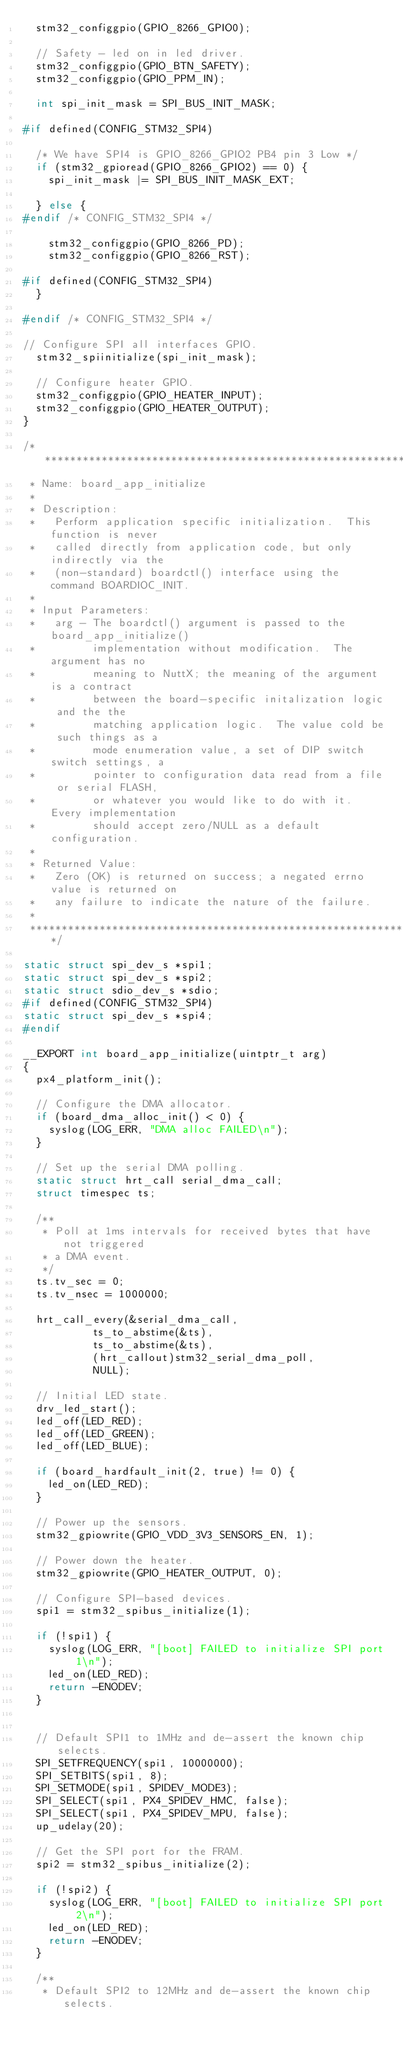Convert code to text. <code><loc_0><loc_0><loc_500><loc_500><_C_>	stm32_configgpio(GPIO_8266_GPIO0);

	// Safety - led on in led driver.
	stm32_configgpio(GPIO_BTN_SAFETY);
	stm32_configgpio(GPIO_PPM_IN);

	int spi_init_mask = SPI_BUS_INIT_MASK;

#if defined(CONFIG_STM32_SPI4)

	/* We have SPI4 is GPIO_8266_GPIO2 PB4 pin 3 Low */
	if (stm32_gpioread(GPIO_8266_GPIO2) == 0) {
		spi_init_mask |= SPI_BUS_INIT_MASK_EXT;

	} else {
#endif /* CONFIG_STM32_SPI4 */

		stm32_configgpio(GPIO_8266_PD);
		stm32_configgpio(GPIO_8266_RST);

#if defined(CONFIG_STM32_SPI4)
	}

#endif /* CONFIG_STM32_SPI4 */

// Configure SPI all interfaces GPIO.
	stm32_spiinitialize(spi_init_mask);

	// Configure heater GPIO.
	stm32_configgpio(GPIO_HEATER_INPUT);
	stm32_configgpio(GPIO_HEATER_OUTPUT);
}

/****************************************************************************
 * Name: board_app_initialize
 *
 * Description:
 *   Perform application specific initialization.  This function is never
 *   called directly from application code, but only indirectly via the
 *   (non-standard) boardctl() interface using the command BOARDIOC_INIT.
 *
 * Input Parameters:
 *   arg - The boardctl() argument is passed to the board_app_initialize()
 *         implementation without modification.  The argument has no
 *         meaning to NuttX; the meaning of the argument is a contract
 *         between the board-specific initalization logic and the the
 *         matching application logic.  The value cold be such things as a
 *         mode enumeration value, a set of DIP switch switch settings, a
 *         pointer to configuration data read from a file or serial FLASH,
 *         or whatever you would like to do with it.  Every implementation
 *         should accept zero/NULL as a default configuration.
 *
 * Returned Value:
 *   Zero (OK) is returned on success; a negated errno value is returned on
 *   any failure to indicate the nature of the failure.
 *
 ****************************************************************************/

static struct spi_dev_s *spi1;
static struct spi_dev_s *spi2;
static struct sdio_dev_s *sdio;
#if defined(CONFIG_STM32_SPI4)
static struct spi_dev_s *spi4;
#endif

__EXPORT int board_app_initialize(uintptr_t arg)
{
	px4_platform_init();

	// Configure the DMA allocator.
	if (board_dma_alloc_init() < 0) {
		syslog(LOG_ERR, "DMA alloc FAILED\n");
	}

	// Set up the serial DMA polling.
	static struct hrt_call serial_dma_call;
	struct timespec ts;

	/**
	 * Poll at 1ms intervals for received bytes that have not triggered
	 * a DMA event.
	 */
	ts.tv_sec = 0;
	ts.tv_nsec = 1000000;

	hrt_call_every(&serial_dma_call,
		       ts_to_abstime(&ts),
		       ts_to_abstime(&ts),
		       (hrt_callout)stm32_serial_dma_poll,
		       NULL);

	// Initial LED state.
	drv_led_start();
	led_off(LED_RED);
	led_off(LED_GREEN);
	led_off(LED_BLUE);

	if (board_hardfault_init(2, true) != 0) {
		led_on(LED_RED);
	}

	// Power up the sensors.
	stm32_gpiowrite(GPIO_VDD_3V3_SENSORS_EN, 1);

	// Power down the heater.
	stm32_gpiowrite(GPIO_HEATER_OUTPUT, 0);

	// Configure SPI-based devices.
	spi1 = stm32_spibus_initialize(1);

	if (!spi1) {
		syslog(LOG_ERR, "[boot] FAILED to initialize SPI port 1\n");
		led_on(LED_RED);
		return -ENODEV;
	}


	// Default SPI1 to 1MHz and de-assert the known chip selects.
	SPI_SETFREQUENCY(spi1, 10000000);
	SPI_SETBITS(spi1, 8);
	SPI_SETMODE(spi1, SPIDEV_MODE3);
	SPI_SELECT(spi1, PX4_SPIDEV_HMC, false);
	SPI_SELECT(spi1, PX4_SPIDEV_MPU, false);
	up_udelay(20);

	// Get the SPI port for the FRAM.
	spi2 = stm32_spibus_initialize(2);

	if (!spi2) {
		syslog(LOG_ERR, "[boot] FAILED to initialize SPI port 2\n");
		led_on(LED_RED);
		return -ENODEV;
	}

	/**
	 * Default SPI2 to 12MHz and de-assert the known chip selects.</code> 